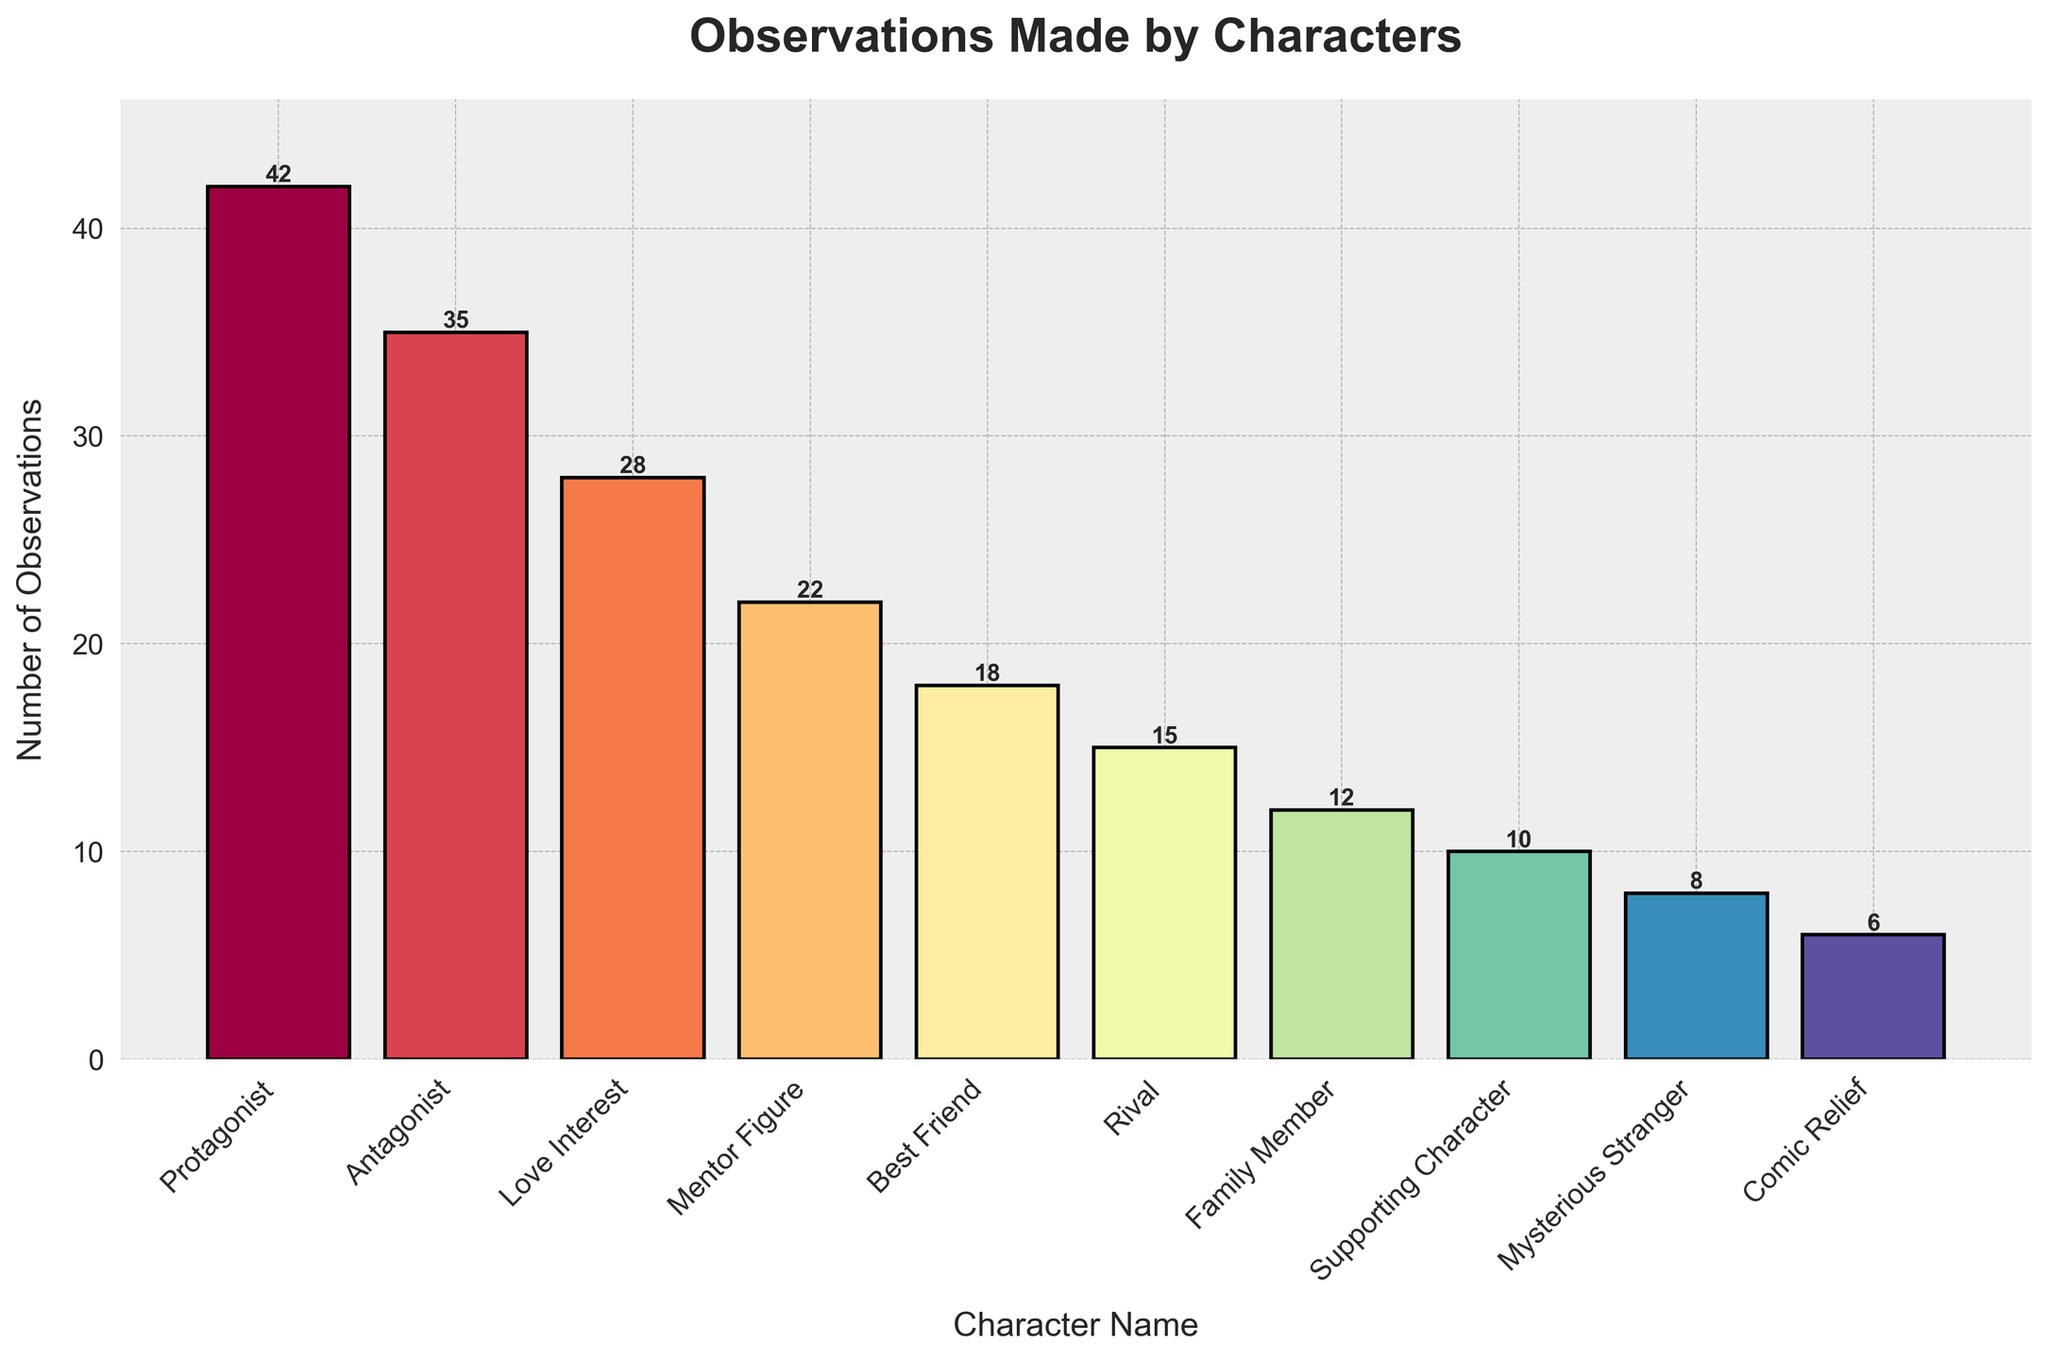Which character has the highest number of observations made? The bar with the greatest height represents the character with the highest number of observations made. The Protagonist's bar is the tallest, indicating 42 observations.
Answer: Protagonist How many total observations were made by the Protagonist and Antagonist combined? The number of observations made by the Protagonist is 42 and by the Antagonist is 35. Adding these together, 42 + 35 results in 77 observations.
Answer: 77 Which character made fewer observations: the Mentor Figure or the Rival? Compare the bar heights of the Mentor Figure (22 observations) and the Rival (15 observations). The Rival has fewer observations.
Answer: Rival How many more observations did the Love Interest make compared to the Comic Relief? The number of observations made by the Love Interest is 28 and by the Comic Relief is 6. Subtracting these, 28 - 6 equals 22 more observations.
Answer: 22 What is the total number of observations made by characters with fewer than 20 observations each? Summing observations for Best Friend (18), Rival (15), Family Member (12), Supporting Character (10), Mysterious Stranger (8), and Comic Relief (6): 18 + 15 + 12 + 10 + 8 + 6 equals 69.
Answer: 69 Which characters have the same color bars? The colors gradually change due to the use of a colormap (Spectral). No two characters have the exact same color as each has a unique gradient.
Answer: None What is the difference in the number of observations between the character with the most observations and the character with the fewest? The Protagonist has 42 observations and the Comic Relief has 6. Subtracting these, 42 - 6 equals a difference of 36.
Answer: 36 What is the average number of observations made per character? Sum the observations of all characters: 42 + 35 + 28 + 22 + 18 + 15 + 12 + 10 + 8 + 6 equals 196. Dividing by the number of characters (10): 196 / 10 equals 19.6.
Answer: 19.6 Rank the characters from the highest to the lowest number of observations made. Based on bar heights: Protagonist (42), Antagonist (35), Love Interest (28), Mentor Figure (22), Best Friend (18), Rival (15), Family Member (12), Supporting Character (10), Mysterious Stranger (8), Comic Relief (6).
Answer: Protagonist > Antagonist > Love Interest > Mentor Figure > Best Friend > Rival > Family Member > Supporting Character > Mysterious Stranger > Comic Relief 